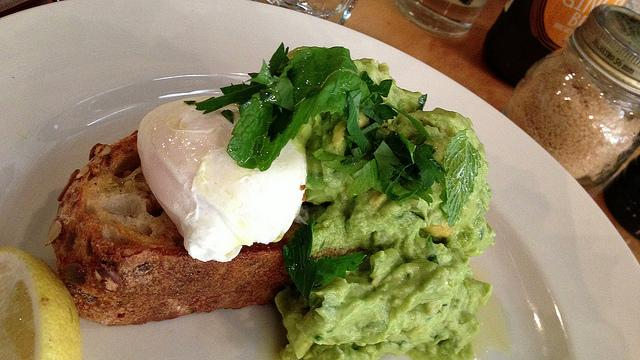What is the light green mixture? guacamole 